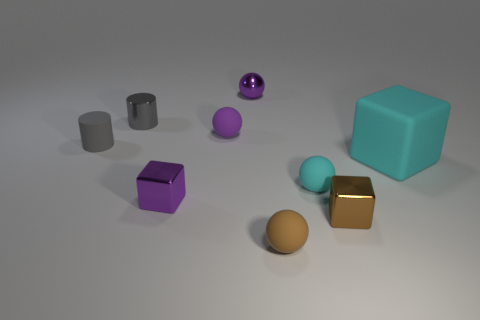Are there fewer shiny balls than tiny gray cylinders?
Provide a short and direct response. Yes. What material is the tiny cube in front of the purple metallic object that is in front of the purple rubber ball?
Provide a succinct answer. Metal. Do the cyan rubber block and the brown rubber ball have the same size?
Offer a very short reply. No. How many objects are purple metal blocks or small cyan metal cubes?
Keep it short and to the point. 1. What is the size of the metallic thing that is both in front of the gray metal cylinder and behind the brown cube?
Your response must be concise. Small. Are there fewer brown balls to the right of the brown rubber object than small gray objects?
Your response must be concise. Yes. What is the shape of the tiny gray object that is the same material as the large cyan cube?
Your answer should be compact. Cylinder. There is a purple shiny thing behind the rubber block; is its shape the same as the tiny purple shiny object that is in front of the shiny sphere?
Keep it short and to the point. No. Is the number of tiny cyan rubber spheres that are to the right of the brown shiny thing less than the number of large rubber cubes to the left of the tiny purple rubber sphere?
Provide a succinct answer. No. There is a tiny metallic thing that is the same color as the shiny ball; what is its shape?
Provide a succinct answer. Cube. 